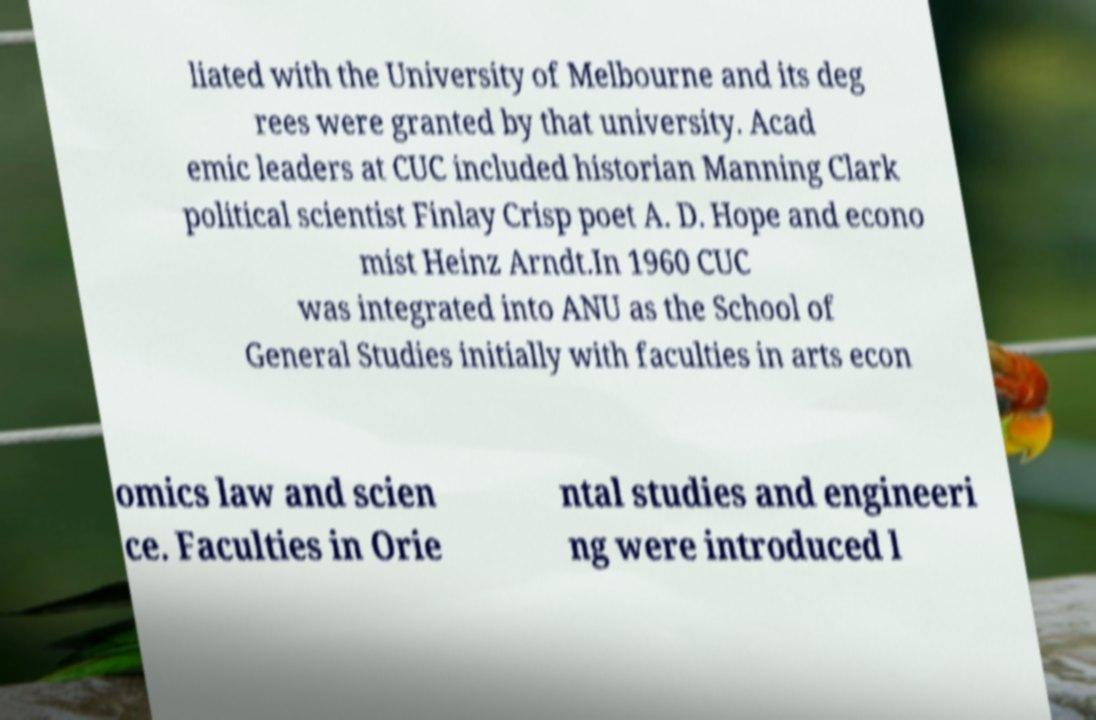Please identify and transcribe the text found in this image. liated with the University of Melbourne and its deg rees were granted by that university. Acad emic leaders at CUC included historian Manning Clark political scientist Finlay Crisp poet A. D. Hope and econo mist Heinz Arndt.In 1960 CUC was integrated into ANU as the School of General Studies initially with faculties in arts econ omics law and scien ce. Faculties in Orie ntal studies and engineeri ng were introduced l 